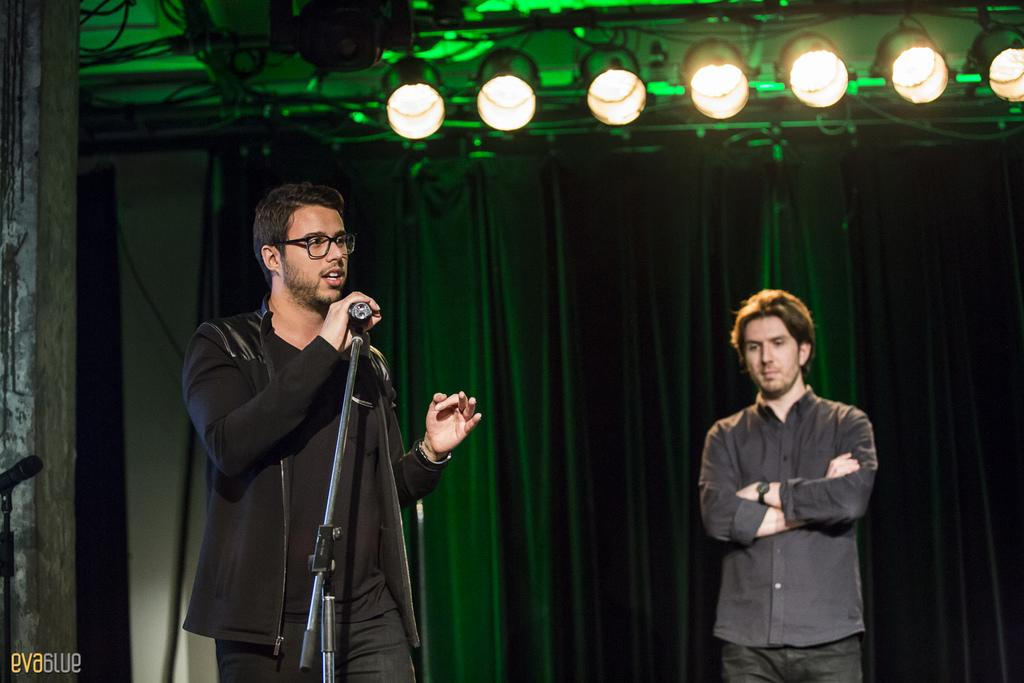How many people are standing in the image? There are two men standing in the image. What is the person with the microphone doing? The person with the microphone is speaking. What can be seen in the image that provides illumination? There are lights visible in the image. What type of horse is present in the image? There is no horse present in the image. What chance does the father have of winning the race in the image? A: There is no father or race present in the image. 